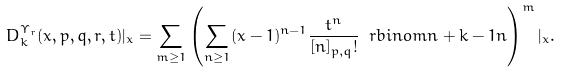<formula> <loc_0><loc_0><loc_500><loc_500>D _ { k } ^ { \Upsilon _ { r } } ( x , p , q , r , t ) | _ { x } = \sum _ { m \geq 1 } \left ( \sum _ { n \geq 1 } ( x - 1 ) ^ { n - 1 } \frac { t ^ { n } } { [ n ] _ { p , q } ! } \ r b i n o m { n + k - 1 } { n } \right ) ^ { m } | _ { x } .</formula> 